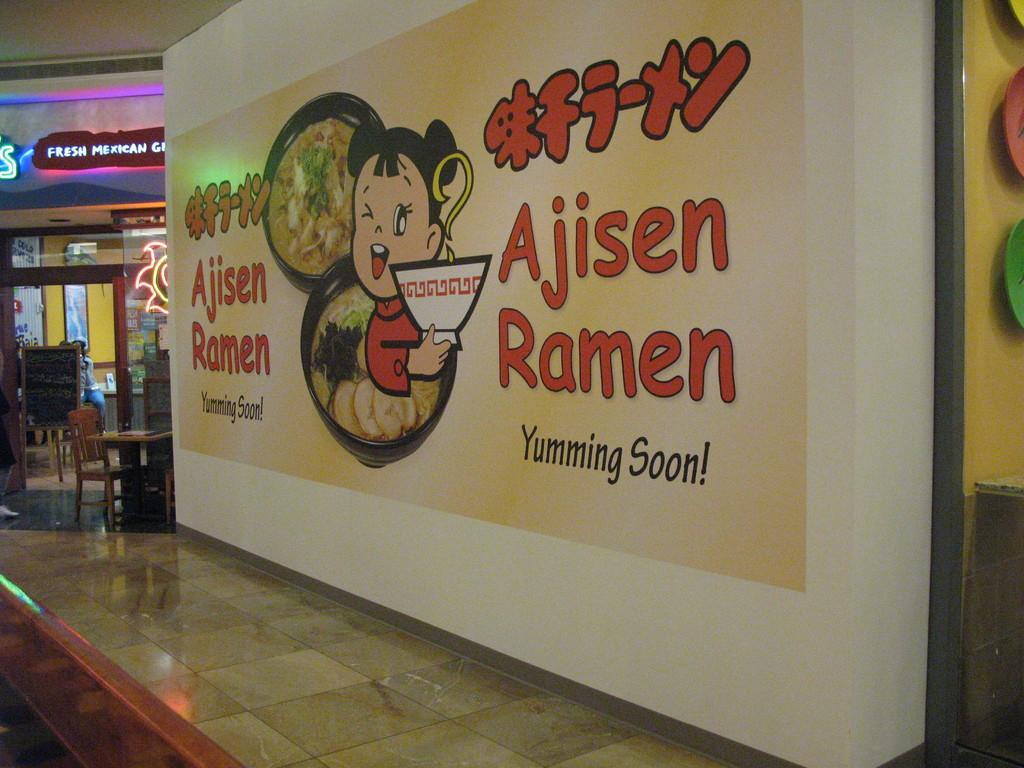Describe this image in one or two sentences. In this picture we can see hoarding and colorful objects on the wall and we can see floor. We can see chairs and table. In the background we can see boards, glass, person, lights and frames on the wall. 